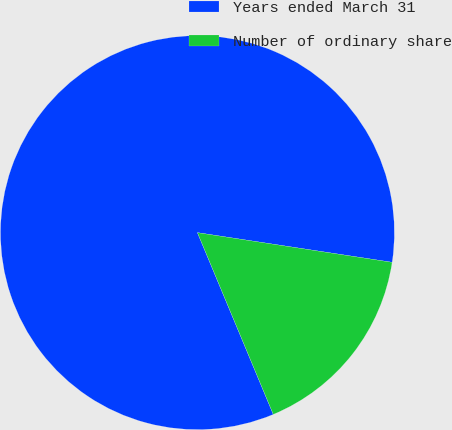Convert chart to OTSL. <chart><loc_0><loc_0><loc_500><loc_500><pie_chart><fcel>Years ended March 31<fcel>Number of ordinary share<nl><fcel>83.7%<fcel>16.3%<nl></chart> 